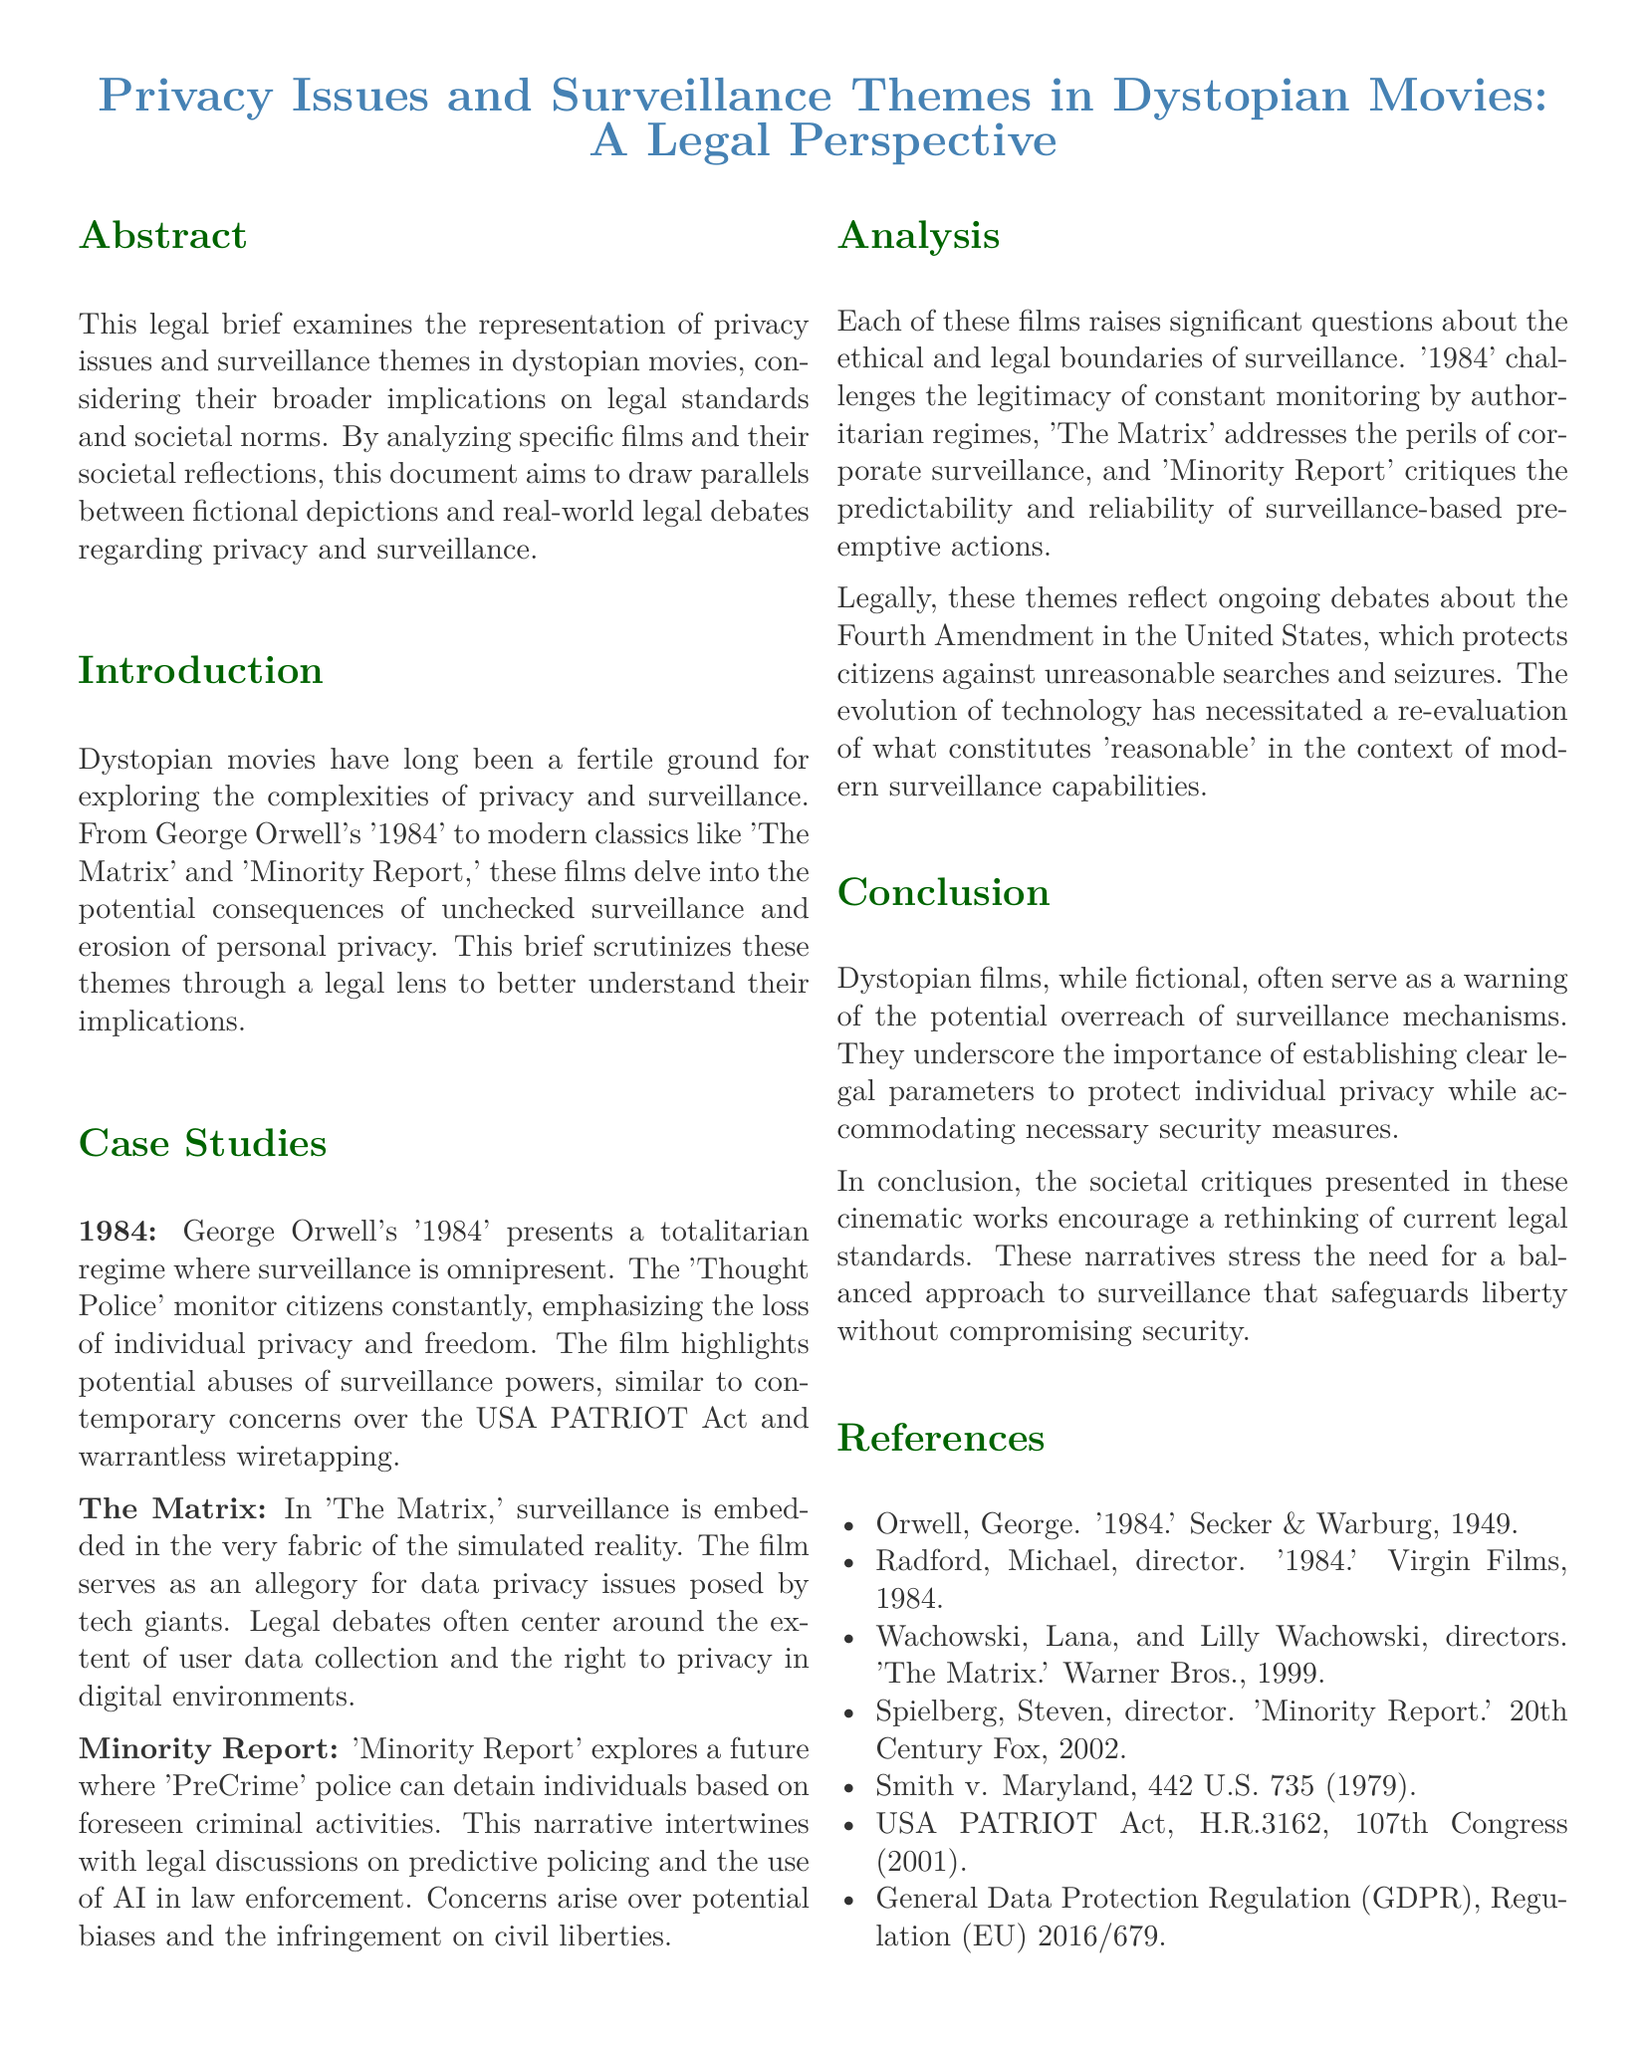What is the title of the document? The title is specified at the beginning of the document, indicating the primary focus of the legal brief.
Answer: Privacy Issues and Surveillance Themes in Dystopian Movies: A Legal Perspective Who directed 'Minority Report'? This information is provided in the references section of the document, citing the director's name associated with the film.
Answer: Steven Spielberg What year was '1984' published? The publication year is noted in the references section, providing the date associated with George Orwell's work.
Answer: 1949 Which film represents a totalitarian regime with constant surveillance? The document explicitly states the film that exemplifies this theme in its case studies section.
Answer: 1984 What legal document is mentioned in relation to warrantless wiretapping? This legal reference is highlighted in the context of contemporary surveillance concerns discussed in the case studies.
Answer: USA PATRIOT Act What is Section 4 about in the document? The document structure indicates that section 4 is dedicated to analyzing the themes of privacy issues and surveillance presented in the films.
Answer: Analysis How many case studies are analyzed in the document? The document specifies the number of case studies discussed in relation to the privacy and surveillance themes.
Answer: Three What is the conclusion's main theme? The conclusion summarizes the overarching message regarding the implications of surveillance mechanisms in society.
Answer: Legal parameters for privacy protection What is the acronym for the regulation mentioned in the references? The acronym for the regulation referenced in relation to data protection is provided in the document.
Answer: GDPR 